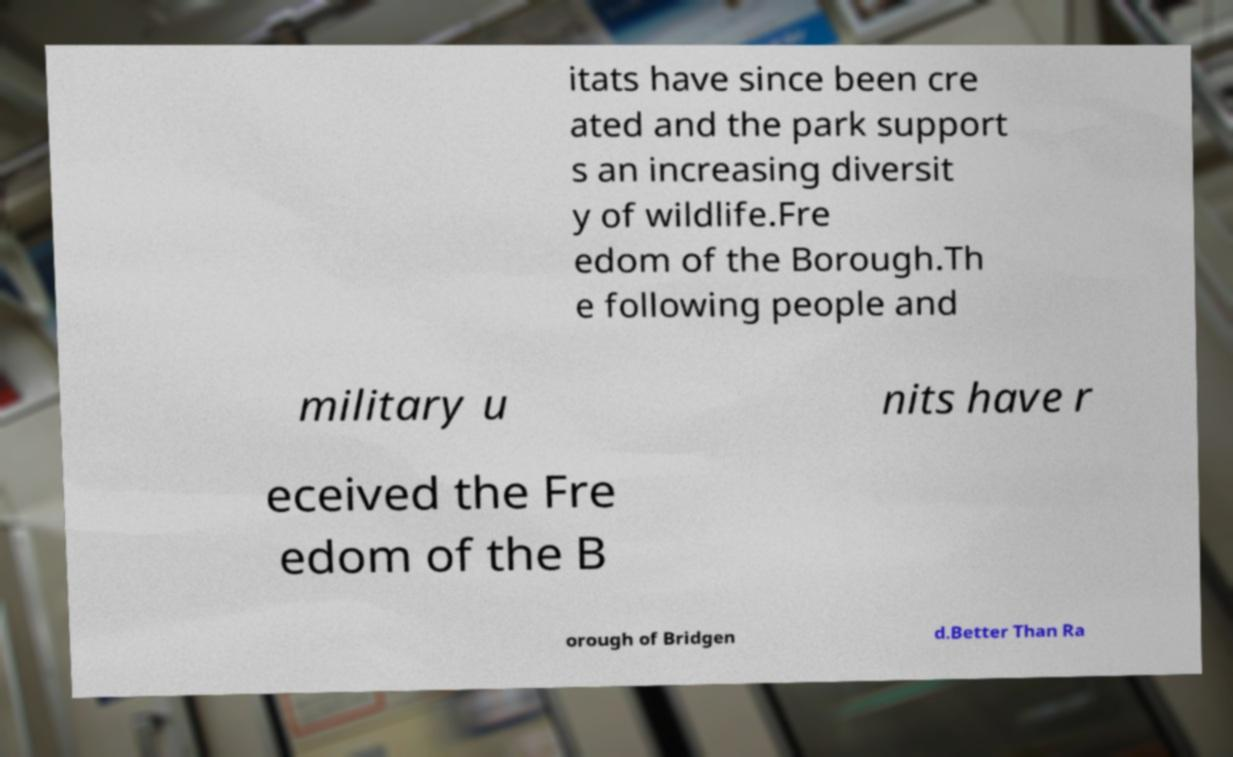Can you read and provide the text displayed in the image?This photo seems to have some interesting text. Can you extract and type it out for me? itats have since been cre ated and the park support s an increasing diversit y of wildlife.Fre edom of the Borough.Th e following people and military u nits have r eceived the Fre edom of the B orough of Bridgen d.Better Than Ra 